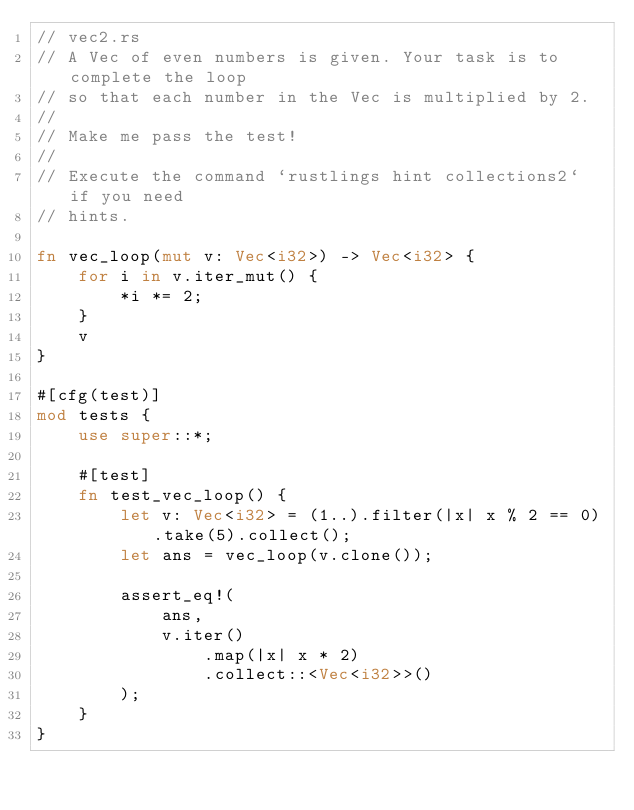<code> <loc_0><loc_0><loc_500><loc_500><_Rust_>// vec2.rs
// A Vec of even numbers is given. Your task is to complete the loop
// so that each number in the Vec is multiplied by 2.
//
// Make me pass the test!
//
// Execute the command `rustlings hint collections2` if you need
// hints.

fn vec_loop(mut v: Vec<i32>) -> Vec<i32> {
    for i in v.iter_mut() {
        *i *= 2;
    }
    v
}

#[cfg(test)]
mod tests {
    use super::*;

    #[test]
    fn test_vec_loop() {
        let v: Vec<i32> = (1..).filter(|x| x % 2 == 0).take(5).collect();
        let ans = vec_loop(v.clone());

        assert_eq!(
            ans,
            v.iter()
                .map(|x| x * 2)
                .collect::<Vec<i32>>()
        );
    }
}
</code> 